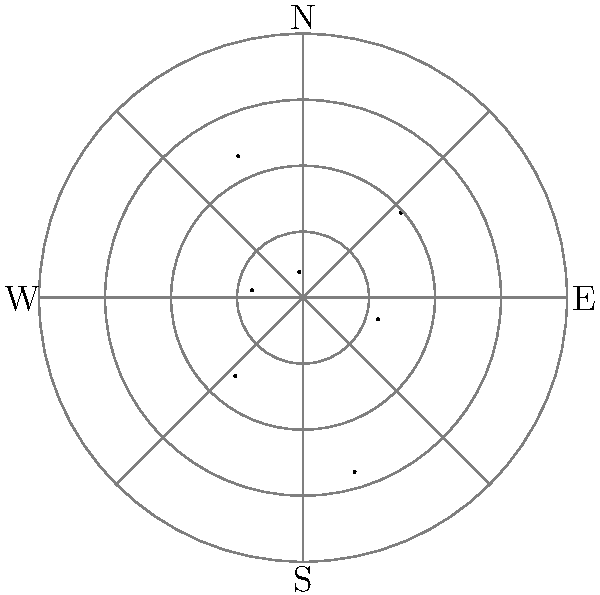Based on the polar rose wind diagram for a forest area, which wind direction poses the greatest potential impact on logging operations due to its high speed? To determine the wind direction with the highest speed, we need to analyze the polar rose diagram:

1. The diagram shows wind speeds in different directions.
2. Each spoke represents a direction (N, NE, E, SE, S, SW, W, NW).
3. The length of each spoke indicates the wind speed in that direction.
4. To find the highest speed, we compare the lengths of all spokes:

   N (0°): 5 units
   NE (45°): 8 units
   E (90°): 3 units
   SE (135°): 6 units
   S (180°): 4 units
   SW (225°): 7 units
   W (270°): 2 units
   NW (315°): 5 units

5. The longest spoke is in the NE direction (45°) with 8 units.

Therefore, the wind from the northeast (NE) direction has the highest speed and potentially the greatest impact on logging operations.
Answer: Northeast (NE) 